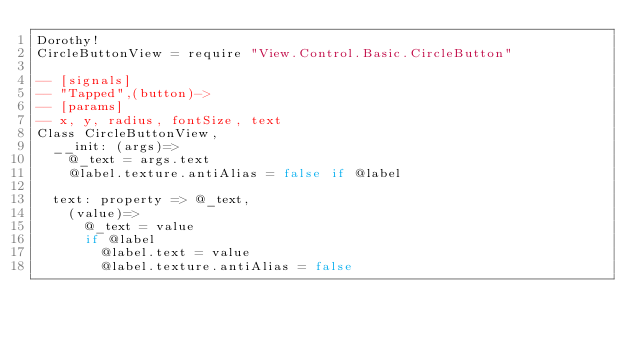Convert code to text. <code><loc_0><loc_0><loc_500><loc_500><_MoonScript_>Dorothy!
CircleButtonView = require "View.Control.Basic.CircleButton"

-- [signals]
-- "Tapped",(button)->
-- [params]
-- x, y, radius, fontSize, text
Class CircleButtonView,
	__init: (args)=>
		@_text = args.text
		@label.texture.antiAlias = false if @label

	text: property => @_text,
		(value)=>
			@_text = value
			if @label
				@label.text = value
				@label.texture.antiAlias = false
</code> 